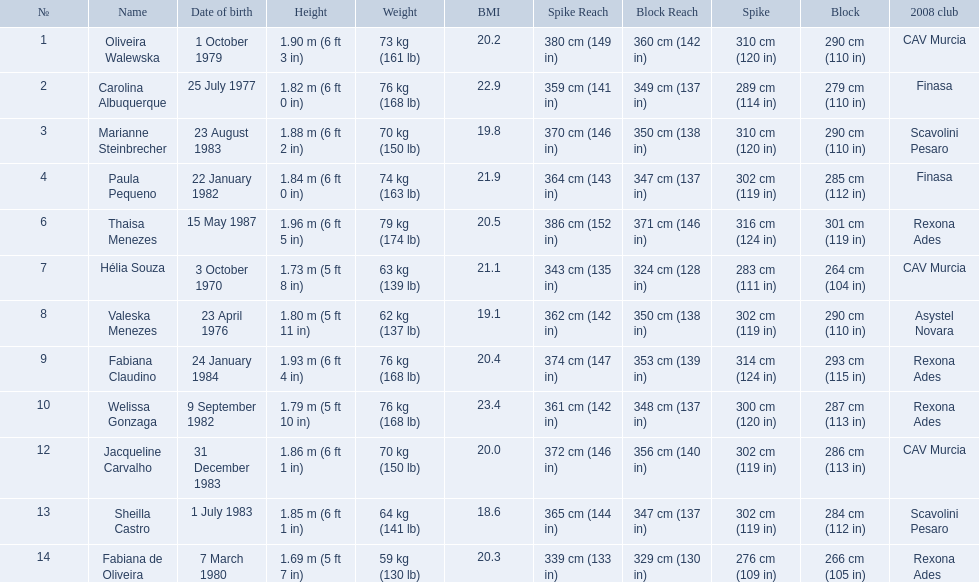What are the names of all the contestants? Oliveira Walewska, Carolina Albuquerque, Marianne Steinbrecher, Paula Pequeno, Thaisa Menezes, Hélia Souza, Valeska Menezes, Fabiana Claudino, Welissa Gonzaga, Jacqueline Carvalho, Sheilla Castro, Fabiana de Oliveira. What are the weight ranges of the contestants? 73 kg (161 lb), 76 kg (168 lb), 70 kg (150 lb), 74 kg (163 lb), 79 kg (174 lb), 63 kg (139 lb), 62 kg (137 lb), 76 kg (168 lb), 76 kg (168 lb), 70 kg (150 lb), 64 kg (141 lb), 59 kg (130 lb). Which player is heaviest. sheilla castro, fabiana de oliveira, or helia souza? Sheilla Castro. 